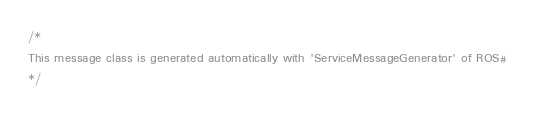<code> <loc_0><loc_0><loc_500><loc_500><_C#_>/*
This message class is generated automatically with 'ServiceMessageGenerator' of ROS#
*/
</code> 